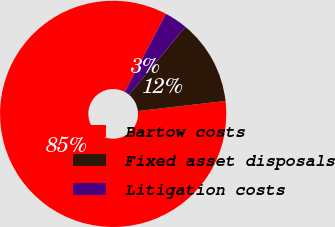Convert chart. <chart><loc_0><loc_0><loc_500><loc_500><pie_chart><fcel>Bartow costs<fcel>Fixed asset disposals<fcel>Litigation costs<nl><fcel>84.53%<fcel>12.15%<fcel>3.31%<nl></chart> 